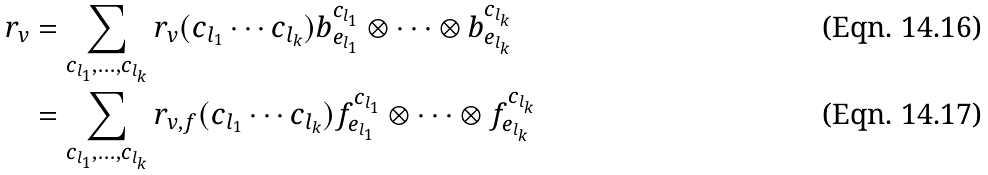<formula> <loc_0><loc_0><loc_500><loc_500>r _ { v } & = \sum _ { c _ { l _ { 1 } } , \dots , c _ { l _ { k } } } r _ { v } ( c _ { l _ { 1 } } \cdots c _ { l _ { k } } ) b _ { e _ { l _ { 1 } } } ^ { c _ { l _ { 1 } } } \otimes \cdots \otimes b _ { e _ { l _ { k } } } ^ { c _ { l _ { k } } } \\ & = \sum _ { c _ { l _ { 1 } } , \dots , c _ { l _ { k } } } r _ { v , f } ( c _ { l _ { 1 } } \cdots c _ { l _ { k } } ) f _ { e _ { l _ { 1 } } } ^ { c _ { l _ { 1 } } } \otimes \cdots \otimes f _ { e _ { l _ { k } } } ^ { c _ { l _ { k } } }</formula> 